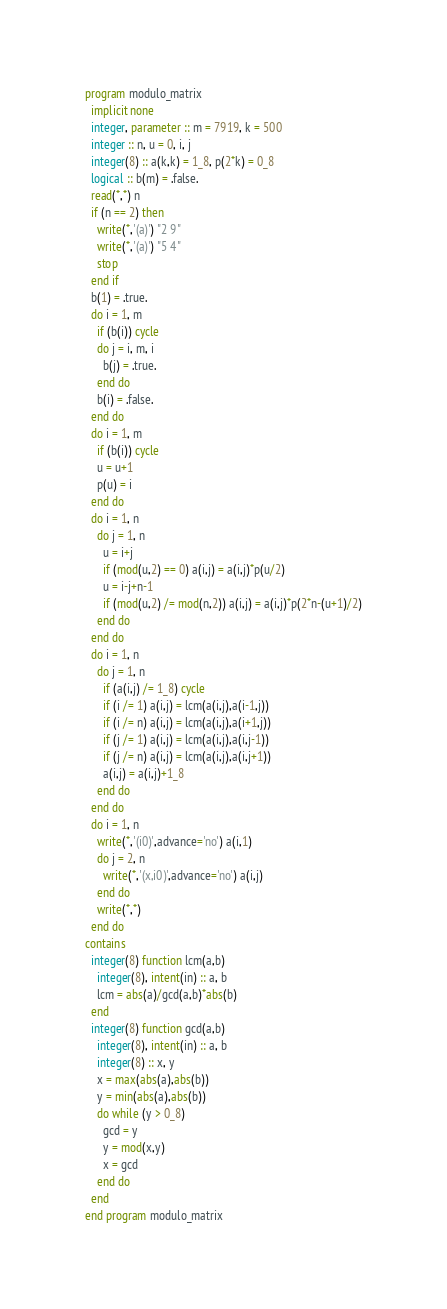<code> <loc_0><loc_0><loc_500><loc_500><_FORTRAN_>program modulo_matrix
  implicit none
  integer, parameter :: m = 7919, k = 500
  integer :: n, u = 0, i, j
  integer(8) :: a(k,k) = 1_8, p(2*k) = 0_8
  logical :: b(m) = .false.
  read(*,*) n
  if (n == 2) then
    write(*,'(a)') "2 9"
    write(*,'(a)') "5 4"
    stop
  end if
  b(1) = .true.
  do i = 1, m
    if (b(i)) cycle
    do j = i, m, i
      b(j) = .true.
    end do
    b(i) = .false.
  end do
  do i = 1, m
    if (b(i)) cycle
    u = u+1
    p(u) = i
  end do
  do i = 1, n
    do j = 1, n
      u = i+j
      if (mod(u,2) == 0) a(i,j) = a(i,j)*p(u/2)
      u = i-j+n-1
      if (mod(u,2) /= mod(n,2)) a(i,j) = a(i,j)*p(2*n-(u+1)/2)
    end do
  end do
  do i = 1, n
    do j = 1, n
      if (a(i,j) /= 1_8) cycle
      if (i /= 1) a(i,j) = lcm(a(i,j),a(i-1,j))
      if (i /= n) a(i,j) = lcm(a(i,j),a(i+1,j))
      if (j /= 1) a(i,j) = lcm(a(i,j),a(i,j-1))
      if (j /= n) a(i,j) = lcm(a(i,j),a(i,j+1))
      a(i,j) = a(i,j)+1_8
    end do
  end do
  do i = 1, n
    write(*,'(i0)',advance='no') a(i,1)
    do j = 2, n
      write(*,'(x,i0)',advance='no') a(i,j)
    end do
    write(*,*)
  end do
contains
  integer(8) function lcm(a,b)
    integer(8), intent(in) :: a, b
    lcm = abs(a)/gcd(a,b)*abs(b)
  end
  integer(8) function gcd(a,b)
    integer(8), intent(in) :: a, b
    integer(8) :: x, y
    x = max(abs(a),abs(b))
    y = min(abs(a),abs(b))
    do while (y > 0_8)
      gcd = y
      y = mod(x,y)
      x = gcd
    end do
  end
end program modulo_matrix</code> 